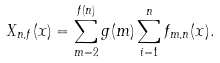<formula> <loc_0><loc_0><loc_500><loc_500>X _ { n , f } ( x ) = \sum _ { m = 2 } ^ { f ( n ) } g ( m ) \sum _ { i = 1 } ^ { n } f _ { m , n } ( x ) .</formula> 